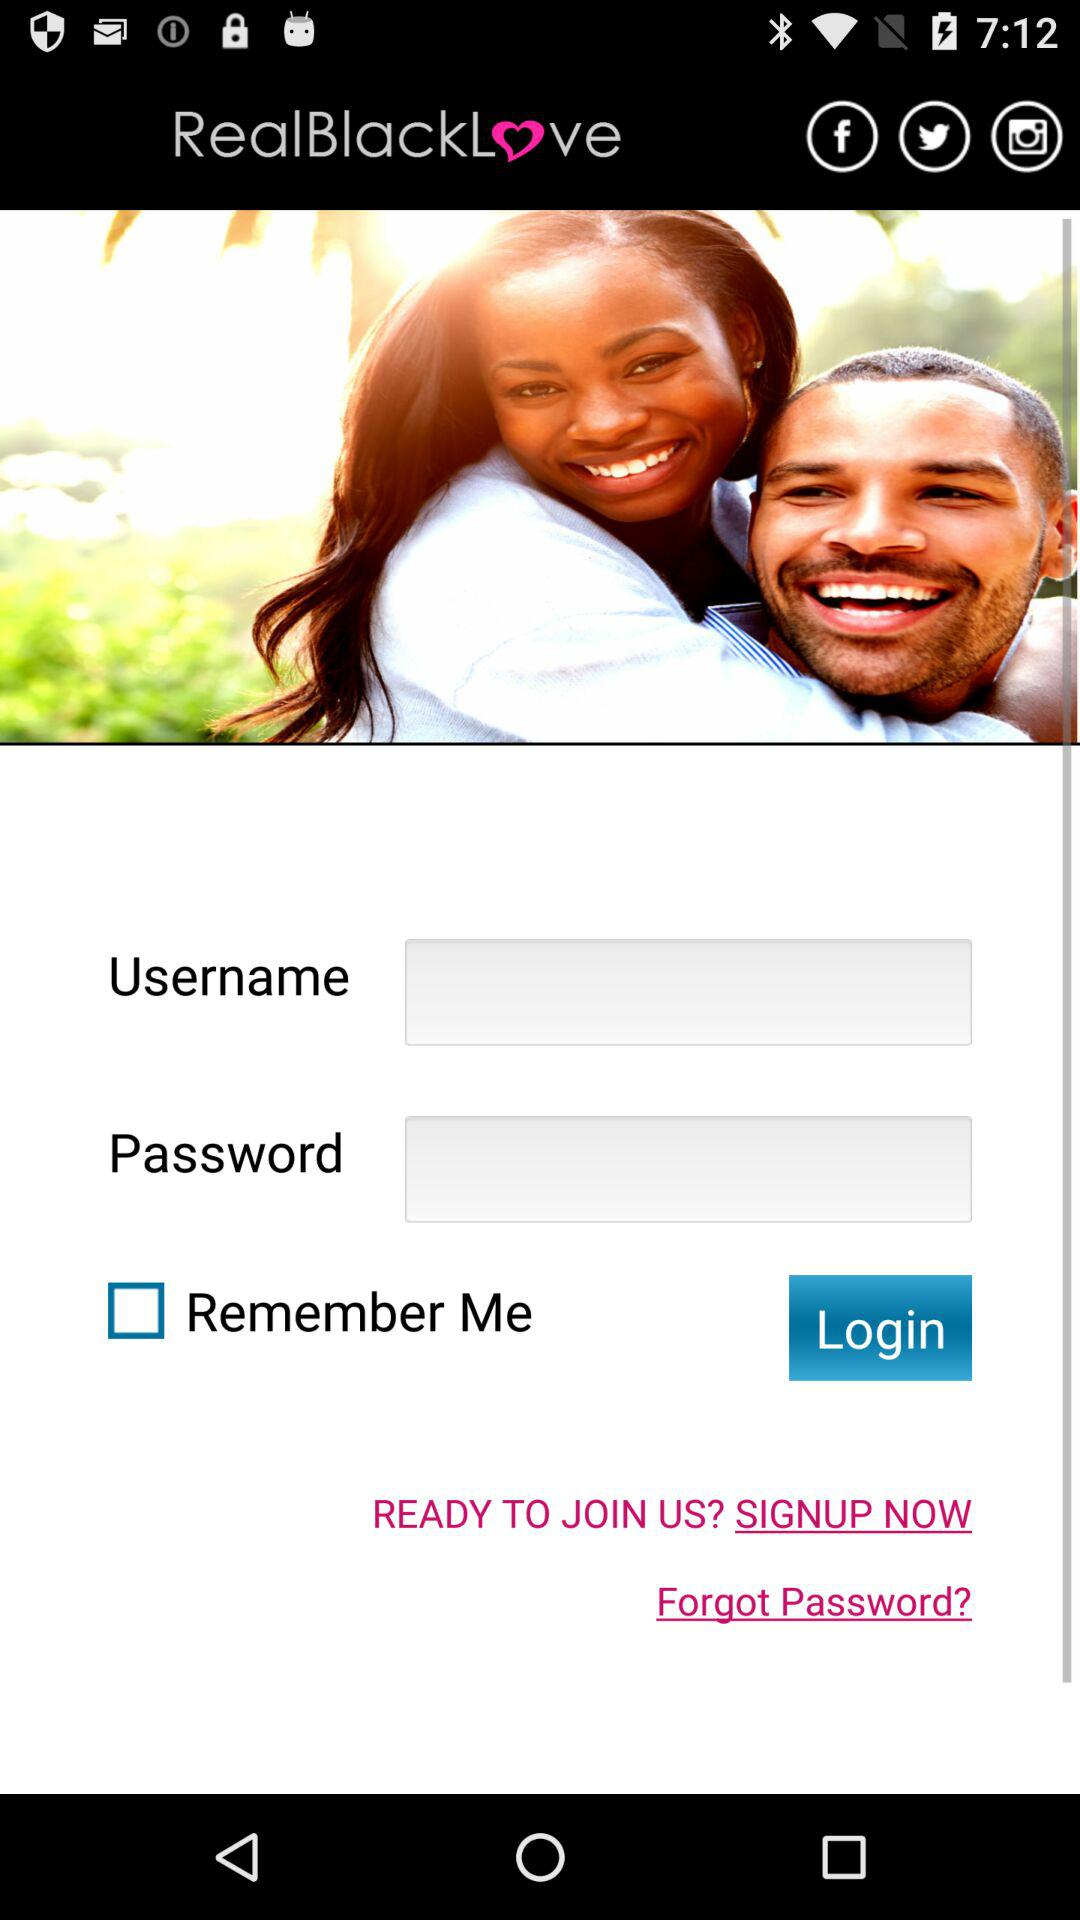What is the status of "Remember Me"? The status is "off". 